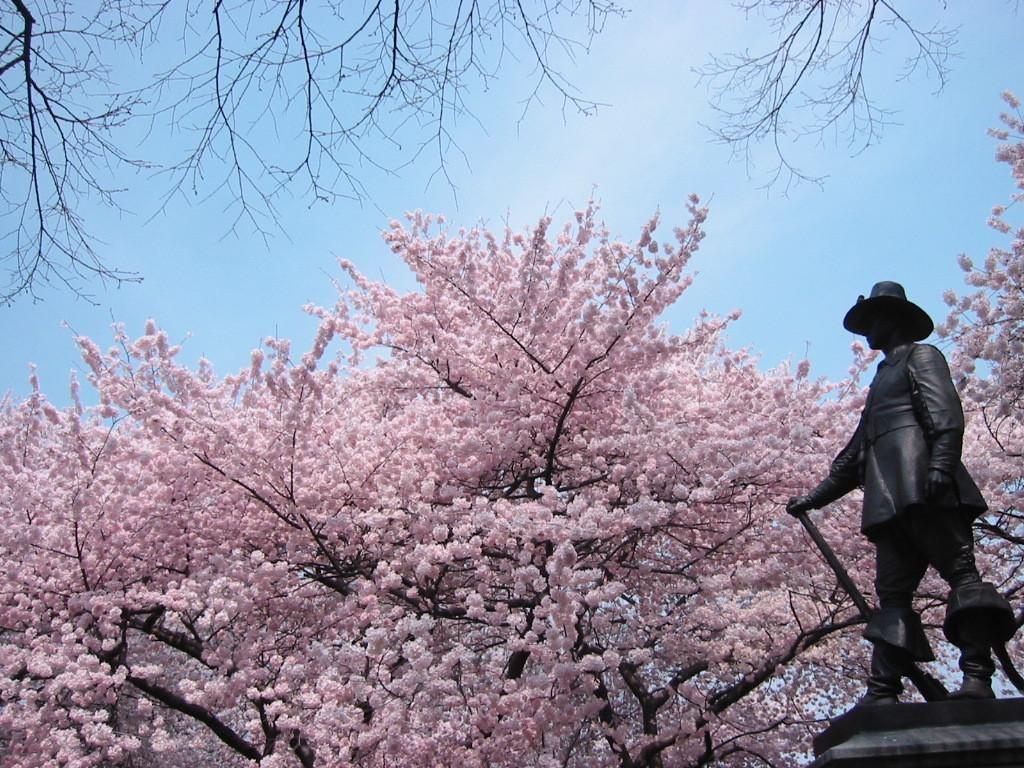How would you summarize this image in a sentence or two? In this image I can see the tree which is in pink color. To the right I can see the statue of the person. In the background there is a sky. 